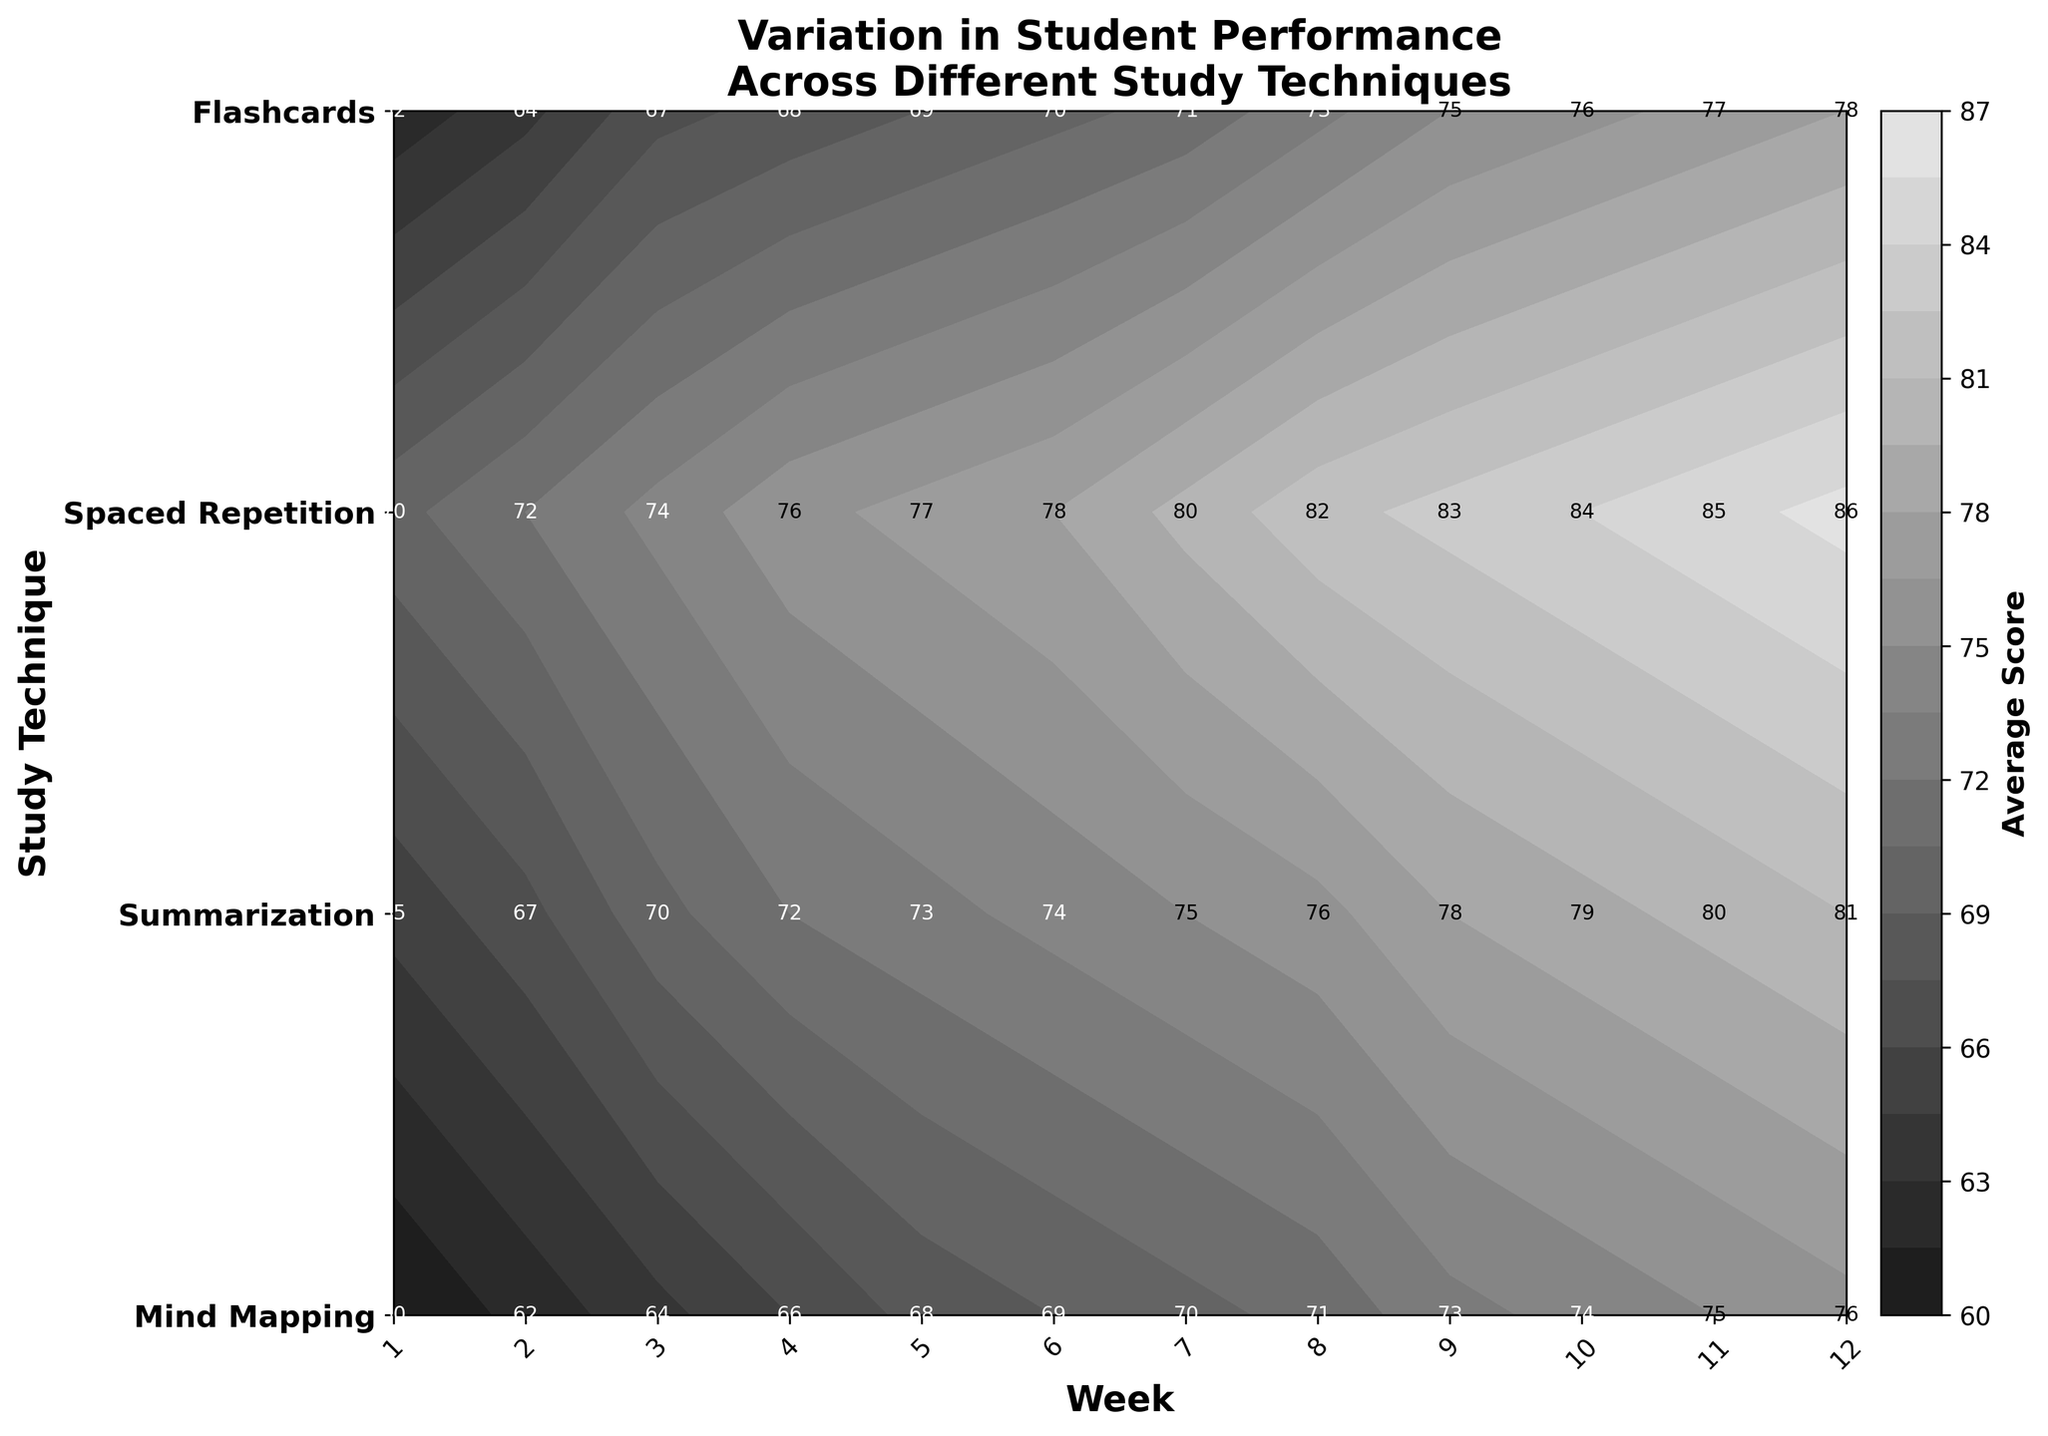What's the title of the figure? The title of the graph is displayed at the top and reads "Variation in Student Performance Across Different Study Techniques."
Answer: Variation in Student Performance Across Different Study Techniques What are the axis labels? The horizontal axis label is "Week," and the vertical axis label is "Study Technique." Both are labeled with bold font.
Answer: Week and Study Technique How many study techniques are compared in the figure? You can count the unique study techniques listed on the vertical axis. There are four study techniques: Mind Mapping, Summarization, Spaced Repetition, and Flashcards.
Answer: 4 Which study technique shows the highest average score by the end of the semester? Observe the highest values along the horizontal axis for each technique. Spaced Repetition shows the highest score of 86 at week 12.
Answer: Spaced Repetition Which weeks show a significant increase in scores for Flashcards? By tracing the scores of Flashcards through the weeks, weeks 4 and 5 show increases from 66 to 68 and from 68 to 69, respectively.  Also, from week 9 to 10, there is an increase from 73 to 74.
Answer: Weeks 4-5 and Weeks 9-10 What is the average score for Summarization in week 6 and week 7? Locate the scores for Summarization at weeks 6 and 7, which are 70 and 71, respectively. Calculate the average: (70 + 71) / 2 = 70.5.
Answer: 70.5 Between Mind Mapping and Summarization, which shows greater improvement over the semester? Calculate the difference between the starting and ending scores for both techniques. Mind Mapping starts at 65 and ends at 81, an improvement of 16 points. Summarization starts at 62 and ends at 78, an improvement of 16 points as well. Both have the same improvement.
Answer: Both How does the average score for Mind Mapping in week 10 compare to the final score for Mind Mapping? Check the score for week 10 (79) and the final score (81). The difference is 81 - 79 = 2.
Answer: The final score is 2 points higher Which study technique shows the steepest increase in performance around the middle of the semester? By visually comparing the slopes of the lines around weeks 5 to 8, Spaced Repetition shows the steepest increase, with scores rising from 77 to 82.
Answer: Spaced Repetition Provide the score range for Flashcards throughout the semester. Identify the minimum and maximum scores for Flashcards, which range from 60 during week 1 to 76 during week 12, giving a range of 16 points.
Answer: 60 to 76 